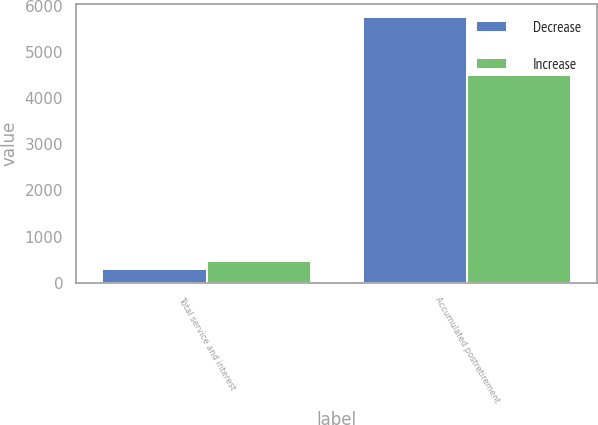Convert chart. <chart><loc_0><loc_0><loc_500><loc_500><stacked_bar_chart><ecel><fcel>Total service and interest<fcel>Accumulated postretirement<nl><fcel>Decrease<fcel>291<fcel>5749<nl><fcel>Increase<fcel>465<fcel>4503<nl></chart> 